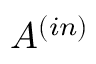Convert formula to latex. <formula><loc_0><loc_0><loc_500><loc_500>A ^ { ( i n ) }</formula> 